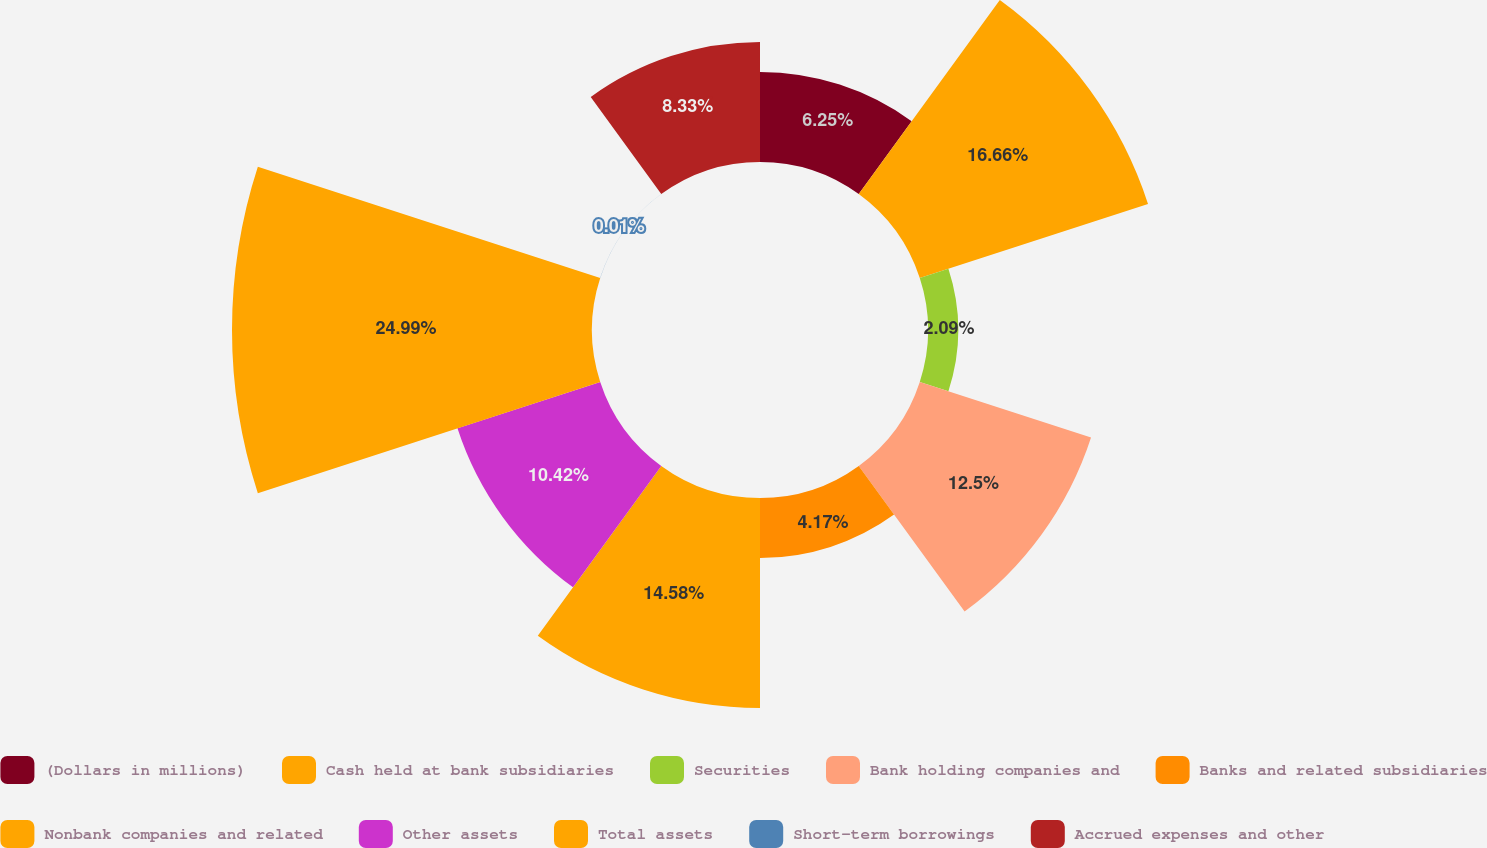<chart> <loc_0><loc_0><loc_500><loc_500><pie_chart><fcel>(Dollars in millions)<fcel>Cash held at bank subsidiaries<fcel>Securities<fcel>Bank holding companies and<fcel>Banks and related subsidiaries<fcel>Nonbank companies and related<fcel>Other assets<fcel>Total assets<fcel>Short-term borrowings<fcel>Accrued expenses and other<nl><fcel>6.25%<fcel>16.66%<fcel>2.09%<fcel>12.5%<fcel>4.17%<fcel>14.58%<fcel>10.42%<fcel>24.99%<fcel>0.01%<fcel>8.33%<nl></chart> 